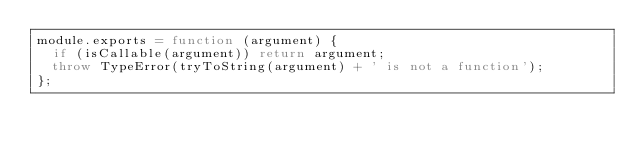Convert code to text. <code><loc_0><loc_0><loc_500><loc_500><_JavaScript_>module.exports = function (argument) {
  if (isCallable(argument)) return argument;
  throw TypeError(tryToString(argument) + ' is not a function');
};
</code> 